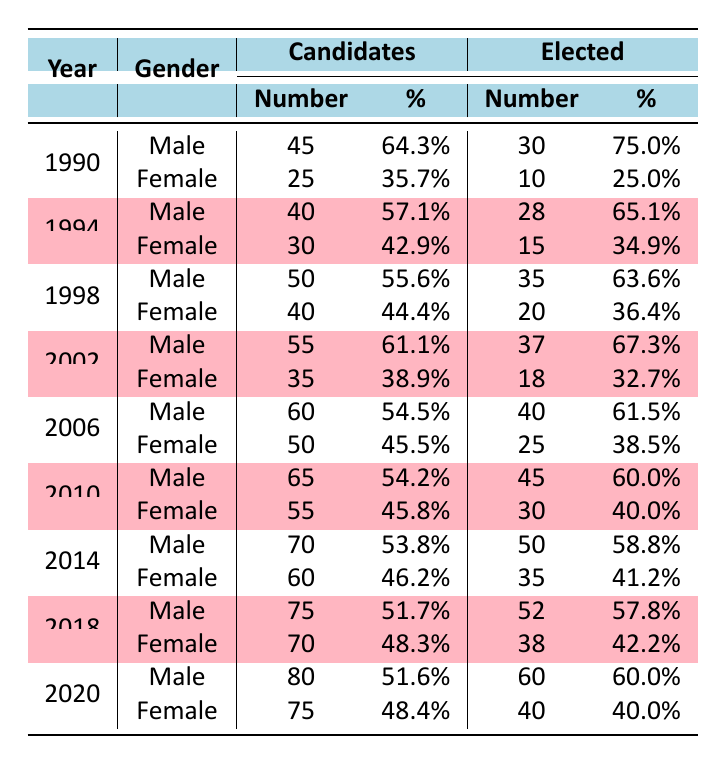What was the total number of male candidates between 1990 and 2020? To find the total number of male candidates, I sum up all the candidates per year for males: 45 (1990) + 40 (1994) + 50 (1998) + 55 (2002) + 60 (2006) + 65 (2010) + 70 (2014) + 75 (2018) + 80 (2020) = 600.
Answer: 600 What was the percentage of elected female candidates in the year 2014? In 2014, the number of female candidates elected was 35, with a total of 60 female candidates. To calculate the percentage, I use the formula (35/60) * 100 = 58.3%.
Answer: 58.3% Did the number of female candidates increase from 2002 to 2018? In 2002, there were 35 female candidates, and in 2018, there were 70 female candidates. Since 70 is greater than 35, the number of female candidates did increase during this period.
Answer: Yes What was the average percentage of elected male candidates from 1990 to 2020? To compute the average percentage of elected males, I first gather the percentages: 75% (1990), 65.1% (1994), 63.6% (1998), 67.3% (2002), 61.5% (2006), 60% (2010), 58.8% (2014), 57.8% (2018), 60% (2020). The total is 75 + 65.1 + 63.6 + 67.3 + 61.5 + 60 + 58.8 + 57.8 + 60 = 619.1, divided by 9, the average is approximately 68.8%.
Answer: 68.8% In which year did female candidates have the highest percentage of election success? I compare the percentages of elected female candidates across all years: 25% (1990), 34.9% (1994), 36.4% (1998), 32.7% (2002), 38.5% (2006), 40% (2010), 41.2% (2014), 42.2% (2018), 40% (2020). The highest is 42.2% in 2018.
Answer: 2018 What is the difference in the number of elected male candidates between 1990 and 2020? The number of elected male candidates in 1990 was 30, and in 2020 it was 60. To find the difference, I subtract: 60 - 30 = 30.
Answer: 30 What was the total number of candidates (male and female combined) in 2006? In 2006, there were 60 male candidates and 50 female candidates. Adding these gives: 60 + 50 = 110 total candidates.
Answer: 110 Was the percentage of elected candidates higher for males or females in 1994? In 1994, males had an elected percentage of 65.1%, while females had 34.9%. Since 65.1% is greater than 34.9%, males had a higher percentage.
Answer: Males What was the trend in the total number of candidates from 1990 to 2020? I analyze the candidates per year: 70 (1990), 70 (1994), 90 (1998), 90 (2002), 110 (2006), 120 (2010), 130 (2014), 145 (2018), 155 (2020). The trend shows a gradual increase over the years.
Answer: Increasing 